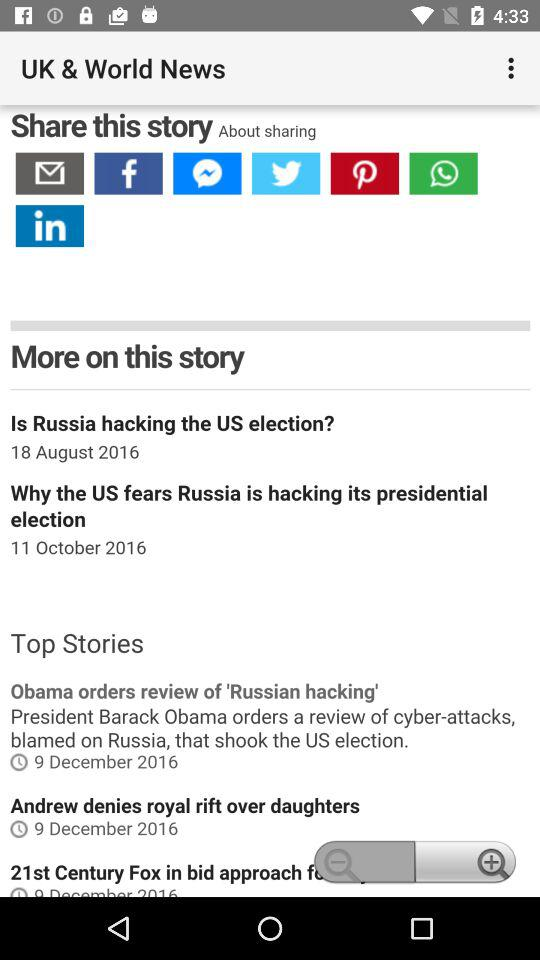What is the name of the application? The name of the application is "UK & World News". 